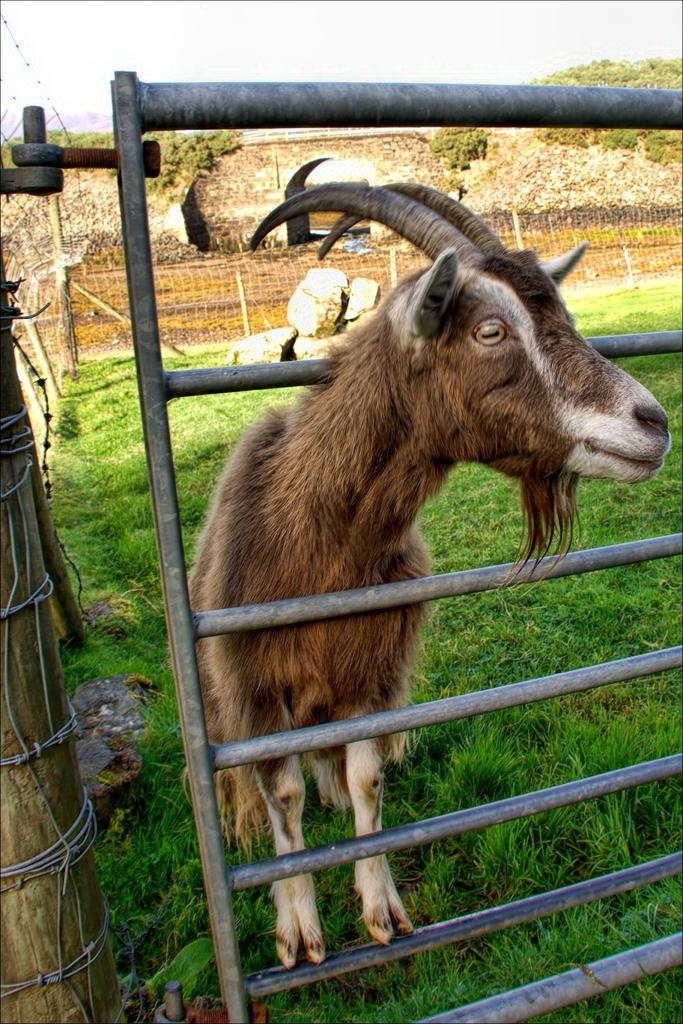What animal can be seen in the image? There is a goat in the image. Where is the goat located in relation to the fence? The goat is behind a fence. What type of fence is visible in the background? There is a wire fence in the background. What type of vegetation is present in the background? Grass is visible in the background. What type of natural features can be seen in the background? Rocks and trees are visible in the background. What type of man-made structures can be seen in the background? A: There is a wall and a bridge present in the background. What part of the natural environment is visible in the background? The sky is visible in the background. What language is the goat speaking in the image? Goats do not speak human languages, so it is not possible to determine what language the goat is speaking in the image. 